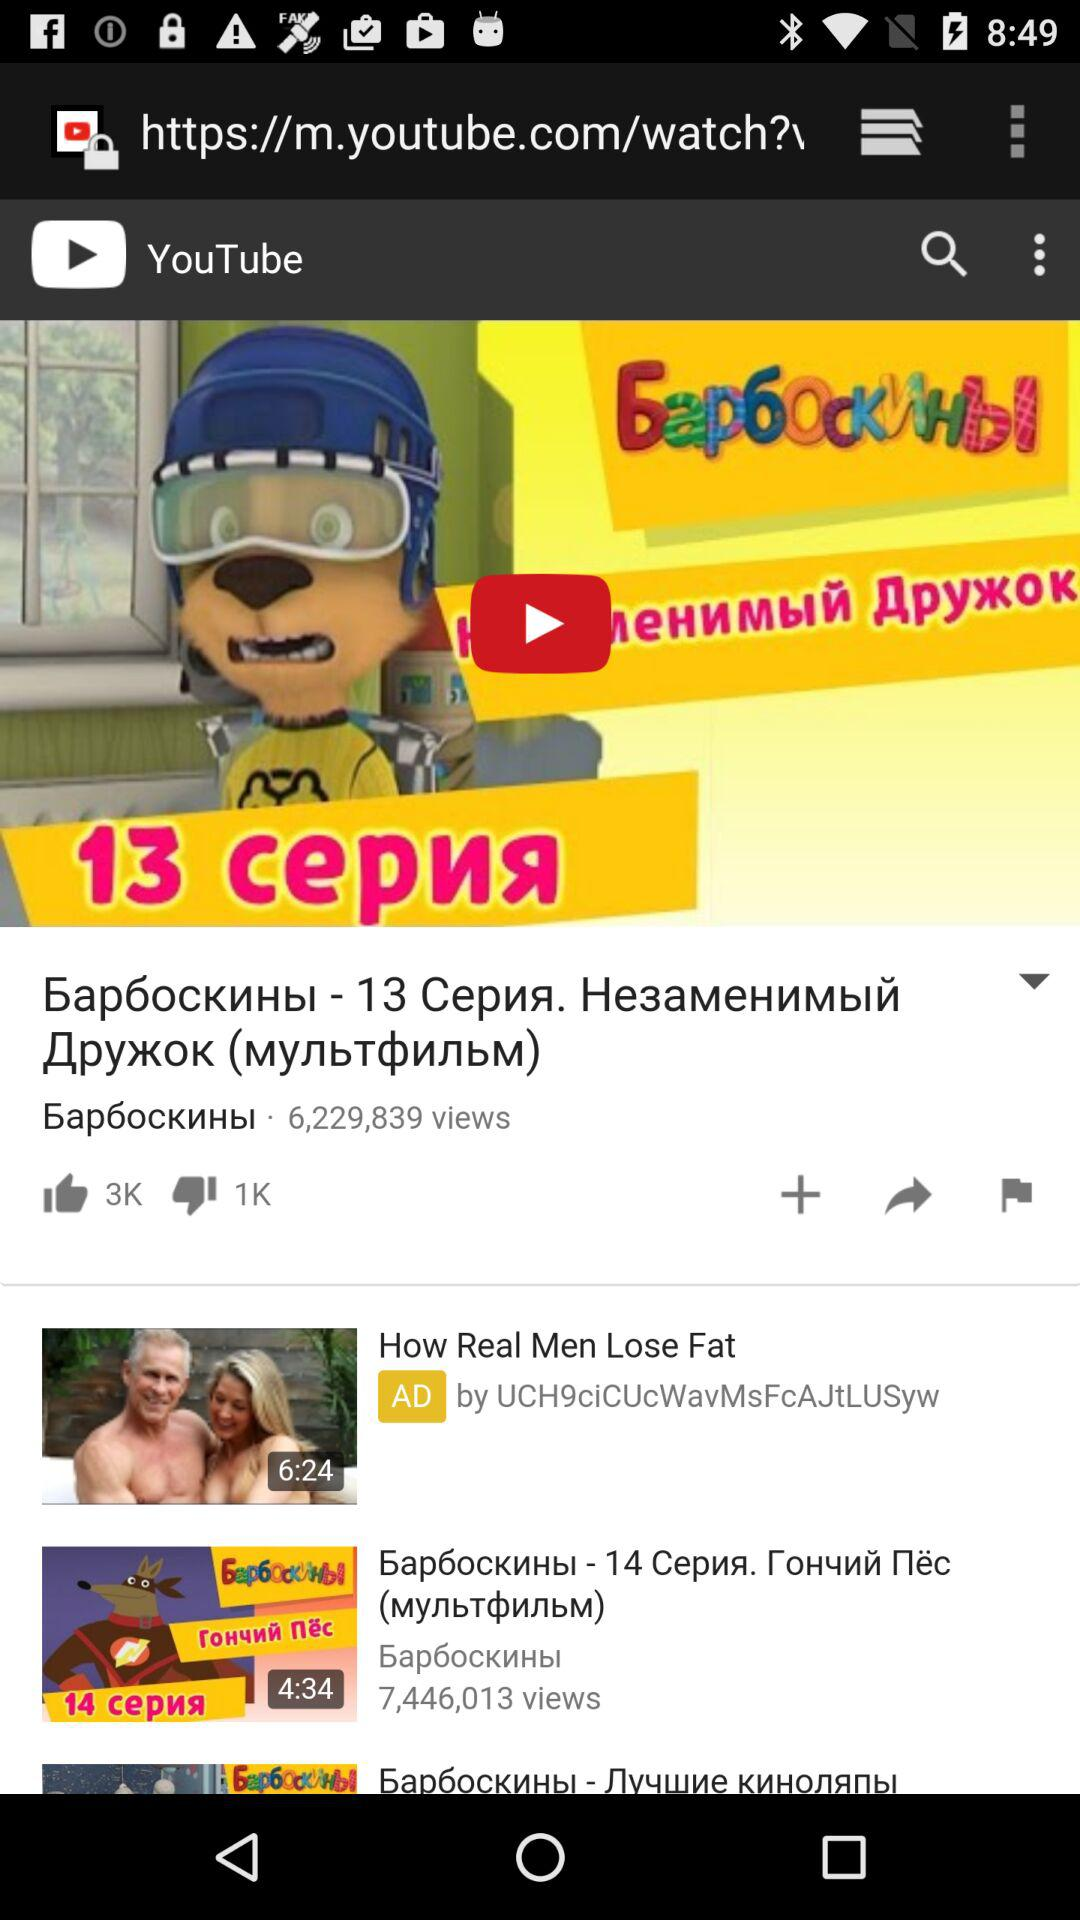How many videos have more than 100k views?
Answer the question using a single word or phrase. 2 